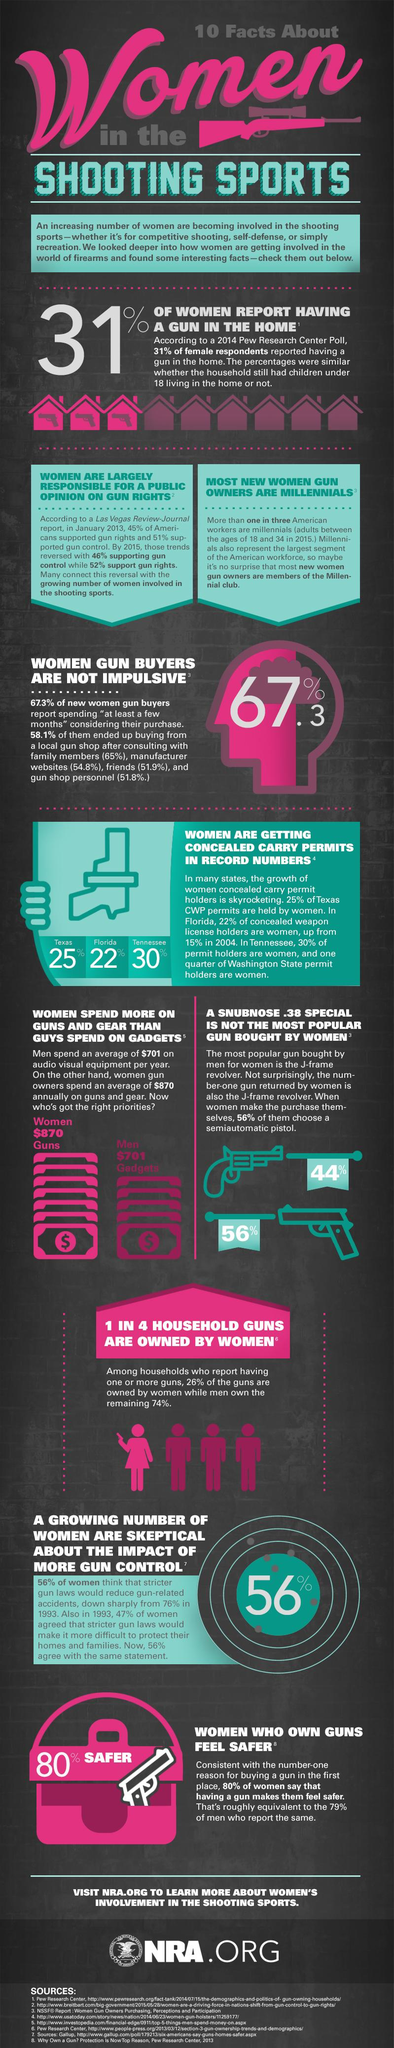Highlight a few significant elements in this photo. According to a study, 32.7% of women who purchase guns are considered to be impulsive. States with a low percentage of women obtaining concealed carry permits include Texas and Florida. 